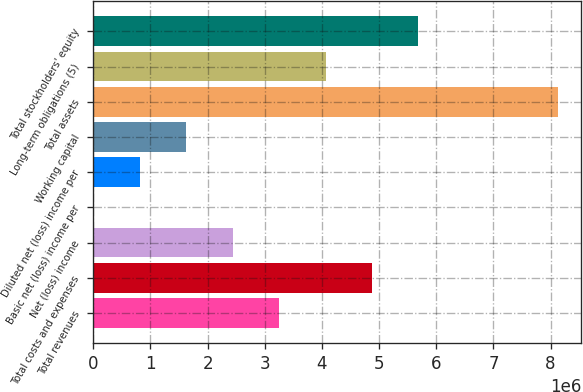Convert chart. <chart><loc_0><loc_0><loc_500><loc_500><bar_chart><fcel>Total revenues<fcel>Total costs and expenses<fcel>Net (loss) income<fcel>Basic net (loss) income per<fcel>Diluted net (loss) income per<fcel>Working capital<fcel>Total assets<fcel>Long-term obligations (5)<fcel>Total stockholders' equity<nl><fcel>3.25073e+06<fcel>4.87609e+06<fcel>2.43804e+06<fcel>1.69<fcel>812683<fcel>1.62536e+06<fcel>8.12681e+06<fcel>4.06341e+06<fcel>5.68877e+06<nl></chart> 